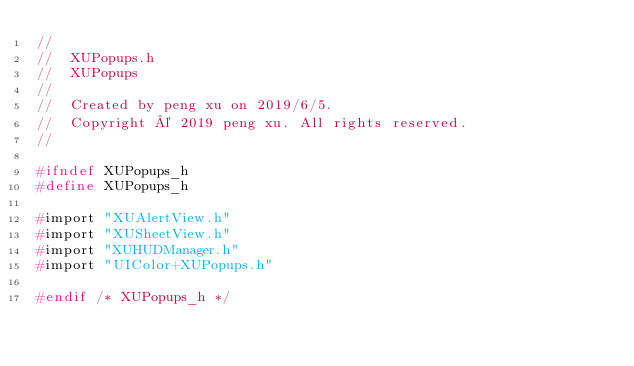Convert code to text. <code><loc_0><loc_0><loc_500><loc_500><_C_>//
//  XUPopups.h
//  XUPopups
//
//  Created by peng xu on 2019/6/5.
//  Copyright © 2019 peng xu. All rights reserved.
//

#ifndef XUPopups_h
#define XUPopups_h

#import "XUAlertView.h"
#import "XUSheetView.h"
#import "XUHUDManager.h"
#import "UIColor+XUPopups.h"

#endif /* XUPopups_h */
</code> 